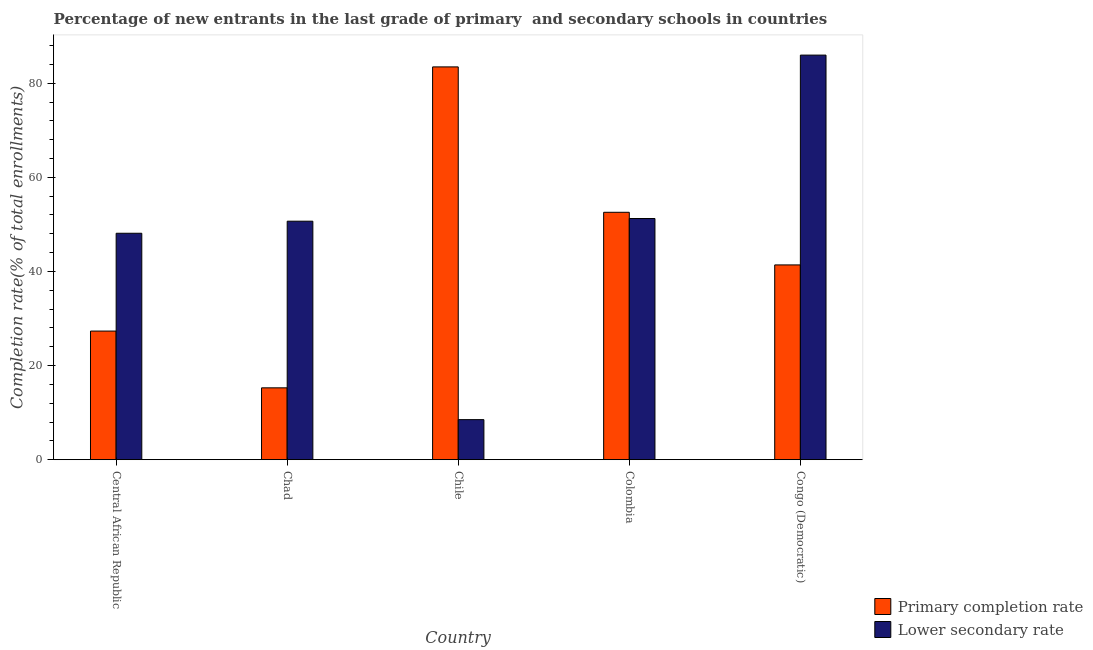How many different coloured bars are there?
Offer a very short reply. 2. How many groups of bars are there?
Keep it short and to the point. 5. Are the number of bars per tick equal to the number of legend labels?
Keep it short and to the point. Yes. Are the number of bars on each tick of the X-axis equal?
Make the answer very short. Yes. How many bars are there on the 3rd tick from the left?
Provide a succinct answer. 2. What is the label of the 5th group of bars from the left?
Your answer should be compact. Congo (Democratic). What is the completion rate in primary schools in Congo (Democratic)?
Offer a terse response. 41.39. Across all countries, what is the maximum completion rate in secondary schools?
Your response must be concise. 85.97. Across all countries, what is the minimum completion rate in secondary schools?
Offer a terse response. 8.51. In which country was the completion rate in secondary schools maximum?
Your answer should be very brief. Congo (Democratic). In which country was the completion rate in primary schools minimum?
Provide a short and direct response. Chad. What is the total completion rate in secondary schools in the graph?
Keep it short and to the point. 244.52. What is the difference between the completion rate in secondary schools in Chad and that in Congo (Democratic)?
Your answer should be compact. -35.29. What is the difference between the completion rate in primary schools in Chad and the completion rate in secondary schools in Central African Republic?
Ensure brevity in your answer.  -32.84. What is the average completion rate in secondary schools per country?
Your response must be concise. 48.9. What is the difference between the completion rate in secondary schools and completion rate in primary schools in Chad?
Your response must be concise. 35.41. What is the ratio of the completion rate in secondary schools in Central African Republic to that in Chad?
Provide a short and direct response. 0.95. What is the difference between the highest and the second highest completion rate in secondary schools?
Your response must be concise. 34.72. What is the difference between the highest and the lowest completion rate in secondary schools?
Offer a very short reply. 77.45. What does the 2nd bar from the left in Central African Republic represents?
Provide a succinct answer. Lower secondary rate. What does the 1st bar from the right in Colombia represents?
Your answer should be compact. Lower secondary rate. How many countries are there in the graph?
Your answer should be compact. 5. What is the difference between two consecutive major ticks on the Y-axis?
Give a very brief answer. 20. Are the values on the major ticks of Y-axis written in scientific E-notation?
Offer a terse response. No. Does the graph contain any zero values?
Your answer should be very brief. No. Does the graph contain grids?
Ensure brevity in your answer.  No. Where does the legend appear in the graph?
Offer a very short reply. Bottom right. How are the legend labels stacked?
Your response must be concise. Vertical. What is the title of the graph?
Offer a very short reply. Percentage of new entrants in the last grade of primary  and secondary schools in countries. Does "Age 65(male)" appear as one of the legend labels in the graph?
Make the answer very short. No. What is the label or title of the Y-axis?
Offer a very short reply. Completion rate(% of total enrollments). What is the Completion rate(% of total enrollments) in Primary completion rate in Central African Republic?
Offer a very short reply. 27.33. What is the Completion rate(% of total enrollments) of Lower secondary rate in Central African Republic?
Keep it short and to the point. 48.11. What is the Completion rate(% of total enrollments) in Primary completion rate in Chad?
Provide a succinct answer. 15.27. What is the Completion rate(% of total enrollments) in Lower secondary rate in Chad?
Your response must be concise. 50.68. What is the Completion rate(% of total enrollments) in Primary completion rate in Chile?
Make the answer very short. 83.46. What is the Completion rate(% of total enrollments) in Lower secondary rate in Chile?
Keep it short and to the point. 8.51. What is the Completion rate(% of total enrollments) in Primary completion rate in Colombia?
Your response must be concise. 52.57. What is the Completion rate(% of total enrollments) in Lower secondary rate in Colombia?
Ensure brevity in your answer.  51.25. What is the Completion rate(% of total enrollments) in Primary completion rate in Congo (Democratic)?
Make the answer very short. 41.39. What is the Completion rate(% of total enrollments) in Lower secondary rate in Congo (Democratic)?
Your response must be concise. 85.97. Across all countries, what is the maximum Completion rate(% of total enrollments) in Primary completion rate?
Offer a very short reply. 83.46. Across all countries, what is the maximum Completion rate(% of total enrollments) of Lower secondary rate?
Give a very brief answer. 85.97. Across all countries, what is the minimum Completion rate(% of total enrollments) in Primary completion rate?
Provide a short and direct response. 15.27. Across all countries, what is the minimum Completion rate(% of total enrollments) of Lower secondary rate?
Keep it short and to the point. 8.51. What is the total Completion rate(% of total enrollments) of Primary completion rate in the graph?
Your answer should be very brief. 220.03. What is the total Completion rate(% of total enrollments) in Lower secondary rate in the graph?
Your answer should be compact. 244.52. What is the difference between the Completion rate(% of total enrollments) in Primary completion rate in Central African Republic and that in Chad?
Offer a terse response. 12.06. What is the difference between the Completion rate(% of total enrollments) of Lower secondary rate in Central African Republic and that in Chad?
Offer a very short reply. -2.56. What is the difference between the Completion rate(% of total enrollments) of Primary completion rate in Central African Republic and that in Chile?
Give a very brief answer. -56.13. What is the difference between the Completion rate(% of total enrollments) in Lower secondary rate in Central African Republic and that in Chile?
Give a very brief answer. 39.6. What is the difference between the Completion rate(% of total enrollments) in Primary completion rate in Central African Republic and that in Colombia?
Your answer should be very brief. -25.24. What is the difference between the Completion rate(% of total enrollments) in Lower secondary rate in Central African Republic and that in Colombia?
Give a very brief answer. -3.13. What is the difference between the Completion rate(% of total enrollments) of Primary completion rate in Central African Republic and that in Congo (Democratic)?
Your response must be concise. -14.06. What is the difference between the Completion rate(% of total enrollments) in Lower secondary rate in Central African Republic and that in Congo (Democratic)?
Ensure brevity in your answer.  -37.85. What is the difference between the Completion rate(% of total enrollments) in Primary completion rate in Chad and that in Chile?
Your answer should be compact. -68.19. What is the difference between the Completion rate(% of total enrollments) in Lower secondary rate in Chad and that in Chile?
Provide a short and direct response. 42.16. What is the difference between the Completion rate(% of total enrollments) of Primary completion rate in Chad and that in Colombia?
Keep it short and to the point. -37.3. What is the difference between the Completion rate(% of total enrollments) of Lower secondary rate in Chad and that in Colombia?
Keep it short and to the point. -0.57. What is the difference between the Completion rate(% of total enrollments) of Primary completion rate in Chad and that in Congo (Democratic)?
Your response must be concise. -26.12. What is the difference between the Completion rate(% of total enrollments) in Lower secondary rate in Chad and that in Congo (Democratic)?
Offer a terse response. -35.29. What is the difference between the Completion rate(% of total enrollments) of Primary completion rate in Chile and that in Colombia?
Offer a terse response. 30.89. What is the difference between the Completion rate(% of total enrollments) in Lower secondary rate in Chile and that in Colombia?
Provide a succinct answer. -42.73. What is the difference between the Completion rate(% of total enrollments) in Primary completion rate in Chile and that in Congo (Democratic)?
Your answer should be very brief. 42.08. What is the difference between the Completion rate(% of total enrollments) of Lower secondary rate in Chile and that in Congo (Democratic)?
Ensure brevity in your answer.  -77.45. What is the difference between the Completion rate(% of total enrollments) of Primary completion rate in Colombia and that in Congo (Democratic)?
Your response must be concise. 11.18. What is the difference between the Completion rate(% of total enrollments) of Lower secondary rate in Colombia and that in Congo (Democratic)?
Your response must be concise. -34.72. What is the difference between the Completion rate(% of total enrollments) of Primary completion rate in Central African Republic and the Completion rate(% of total enrollments) of Lower secondary rate in Chad?
Your answer should be very brief. -23.35. What is the difference between the Completion rate(% of total enrollments) in Primary completion rate in Central African Republic and the Completion rate(% of total enrollments) in Lower secondary rate in Chile?
Give a very brief answer. 18.82. What is the difference between the Completion rate(% of total enrollments) of Primary completion rate in Central African Republic and the Completion rate(% of total enrollments) of Lower secondary rate in Colombia?
Offer a terse response. -23.92. What is the difference between the Completion rate(% of total enrollments) of Primary completion rate in Central African Republic and the Completion rate(% of total enrollments) of Lower secondary rate in Congo (Democratic)?
Give a very brief answer. -58.64. What is the difference between the Completion rate(% of total enrollments) in Primary completion rate in Chad and the Completion rate(% of total enrollments) in Lower secondary rate in Chile?
Offer a terse response. 6.76. What is the difference between the Completion rate(% of total enrollments) of Primary completion rate in Chad and the Completion rate(% of total enrollments) of Lower secondary rate in Colombia?
Provide a short and direct response. -35.98. What is the difference between the Completion rate(% of total enrollments) of Primary completion rate in Chad and the Completion rate(% of total enrollments) of Lower secondary rate in Congo (Democratic)?
Keep it short and to the point. -70.7. What is the difference between the Completion rate(% of total enrollments) of Primary completion rate in Chile and the Completion rate(% of total enrollments) of Lower secondary rate in Colombia?
Ensure brevity in your answer.  32.22. What is the difference between the Completion rate(% of total enrollments) of Primary completion rate in Chile and the Completion rate(% of total enrollments) of Lower secondary rate in Congo (Democratic)?
Offer a terse response. -2.5. What is the difference between the Completion rate(% of total enrollments) in Primary completion rate in Colombia and the Completion rate(% of total enrollments) in Lower secondary rate in Congo (Democratic)?
Keep it short and to the point. -33.4. What is the average Completion rate(% of total enrollments) in Primary completion rate per country?
Offer a very short reply. 44.01. What is the average Completion rate(% of total enrollments) of Lower secondary rate per country?
Your answer should be very brief. 48.9. What is the difference between the Completion rate(% of total enrollments) in Primary completion rate and Completion rate(% of total enrollments) in Lower secondary rate in Central African Republic?
Ensure brevity in your answer.  -20.78. What is the difference between the Completion rate(% of total enrollments) in Primary completion rate and Completion rate(% of total enrollments) in Lower secondary rate in Chad?
Your answer should be compact. -35.41. What is the difference between the Completion rate(% of total enrollments) in Primary completion rate and Completion rate(% of total enrollments) in Lower secondary rate in Chile?
Provide a short and direct response. 74.95. What is the difference between the Completion rate(% of total enrollments) in Primary completion rate and Completion rate(% of total enrollments) in Lower secondary rate in Colombia?
Make the answer very short. 1.32. What is the difference between the Completion rate(% of total enrollments) in Primary completion rate and Completion rate(% of total enrollments) in Lower secondary rate in Congo (Democratic)?
Keep it short and to the point. -44.58. What is the ratio of the Completion rate(% of total enrollments) of Primary completion rate in Central African Republic to that in Chad?
Offer a very short reply. 1.79. What is the ratio of the Completion rate(% of total enrollments) of Lower secondary rate in Central African Republic to that in Chad?
Keep it short and to the point. 0.95. What is the ratio of the Completion rate(% of total enrollments) of Primary completion rate in Central African Republic to that in Chile?
Make the answer very short. 0.33. What is the ratio of the Completion rate(% of total enrollments) in Lower secondary rate in Central African Republic to that in Chile?
Provide a succinct answer. 5.65. What is the ratio of the Completion rate(% of total enrollments) in Primary completion rate in Central African Republic to that in Colombia?
Give a very brief answer. 0.52. What is the ratio of the Completion rate(% of total enrollments) in Lower secondary rate in Central African Republic to that in Colombia?
Offer a terse response. 0.94. What is the ratio of the Completion rate(% of total enrollments) in Primary completion rate in Central African Republic to that in Congo (Democratic)?
Your response must be concise. 0.66. What is the ratio of the Completion rate(% of total enrollments) of Lower secondary rate in Central African Republic to that in Congo (Democratic)?
Ensure brevity in your answer.  0.56. What is the ratio of the Completion rate(% of total enrollments) in Primary completion rate in Chad to that in Chile?
Your response must be concise. 0.18. What is the ratio of the Completion rate(% of total enrollments) in Lower secondary rate in Chad to that in Chile?
Your answer should be very brief. 5.95. What is the ratio of the Completion rate(% of total enrollments) of Primary completion rate in Chad to that in Colombia?
Provide a succinct answer. 0.29. What is the ratio of the Completion rate(% of total enrollments) in Lower secondary rate in Chad to that in Colombia?
Your answer should be compact. 0.99. What is the ratio of the Completion rate(% of total enrollments) of Primary completion rate in Chad to that in Congo (Democratic)?
Your response must be concise. 0.37. What is the ratio of the Completion rate(% of total enrollments) in Lower secondary rate in Chad to that in Congo (Democratic)?
Give a very brief answer. 0.59. What is the ratio of the Completion rate(% of total enrollments) in Primary completion rate in Chile to that in Colombia?
Give a very brief answer. 1.59. What is the ratio of the Completion rate(% of total enrollments) in Lower secondary rate in Chile to that in Colombia?
Give a very brief answer. 0.17. What is the ratio of the Completion rate(% of total enrollments) of Primary completion rate in Chile to that in Congo (Democratic)?
Provide a short and direct response. 2.02. What is the ratio of the Completion rate(% of total enrollments) of Lower secondary rate in Chile to that in Congo (Democratic)?
Provide a short and direct response. 0.1. What is the ratio of the Completion rate(% of total enrollments) of Primary completion rate in Colombia to that in Congo (Democratic)?
Offer a very short reply. 1.27. What is the ratio of the Completion rate(% of total enrollments) of Lower secondary rate in Colombia to that in Congo (Democratic)?
Your response must be concise. 0.6. What is the difference between the highest and the second highest Completion rate(% of total enrollments) in Primary completion rate?
Ensure brevity in your answer.  30.89. What is the difference between the highest and the second highest Completion rate(% of total enrollments) in Lower secondary rate?
Your answer should be compact. 34.72. What is the difference between the highest and the lowest Completion rate(% of total enrollments) in Primary completion rate?
Your answer should be compact. 68.19. What is the difference between the highest and the lowest Completion rate(% of total enrollments) of Lower secondary rate?
Give a very brief answer. 77.45. 